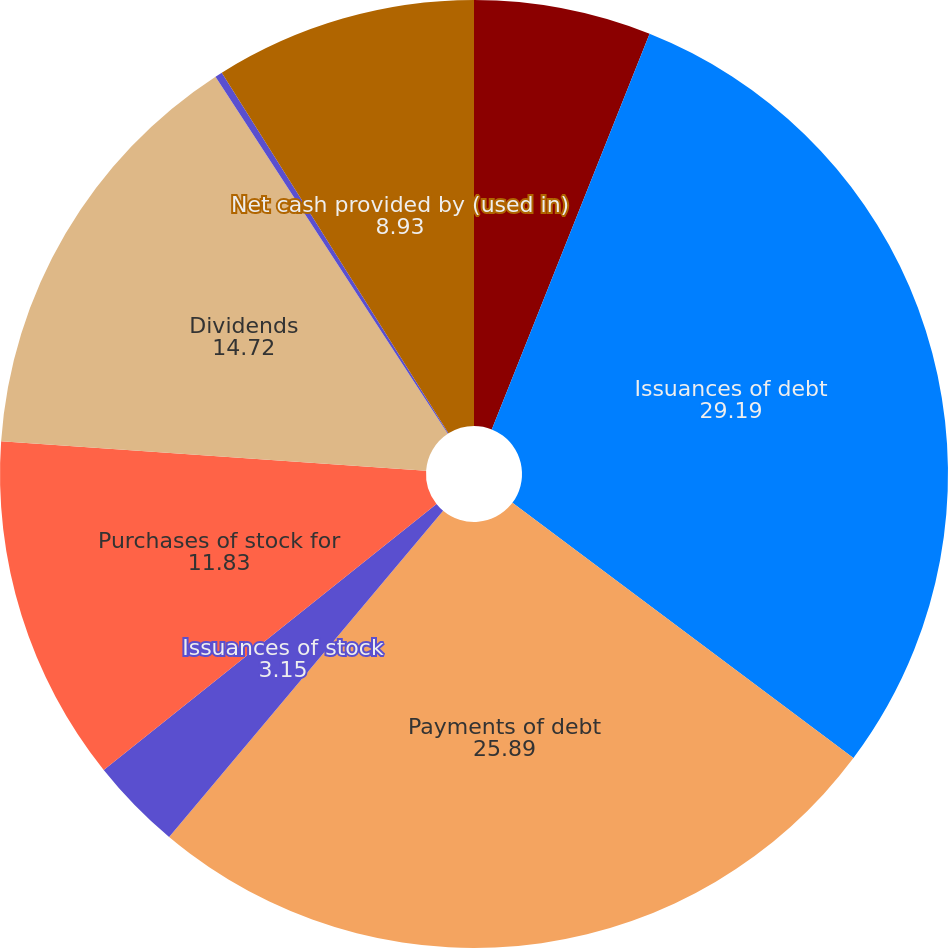Convert chart to OTSL. <chart><loc_0><loc_0><loc_500><loc_500><pie_chart><fcel>Year Ended December 31<fcel>Issuances of debt<fcel>Payments of debt<fcel>Issuances of stock<fcel>Purchases of stock for<fcel>Dividends<fcel>Other financing activities<fcel>Net cash provided by (used in)<nl><fcel>6.04%<fcel>29.19%<fcel>25.89%<fcel>3.15%<fcel>11.83%<fcel>14.72%<fcel>0.25%<fcel>8.93%<nl></chart> 